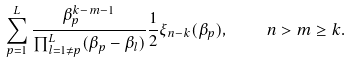Convert formula to latex. <formula><loc_0><loc_0><loc_500><loc_500>\sum ^ { L } _ { p = 1 } \frac { \beta ^ { k - m - 1 } _ { p } } { \prod ^ { L } _ { l = 1 \neq p } ( \beta _ { p } - \beta _ { l } ) } \frac { 1 } { 2 } \xi _ { n - k } ( \beta _ { p } ) , \quad n > m \geq k .</formula> 